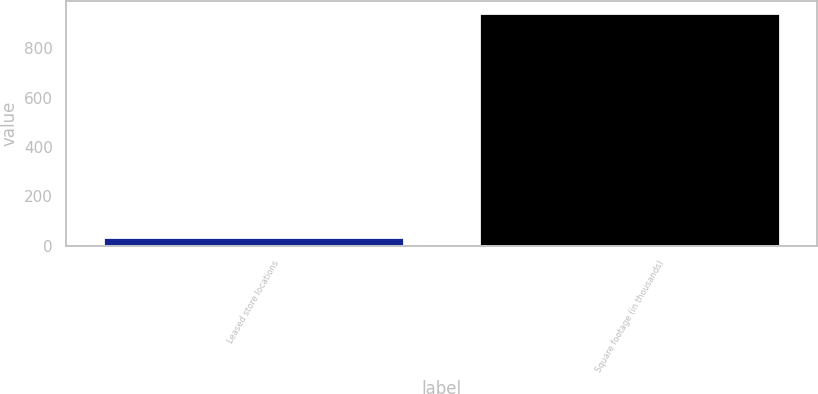<chart> <loc_0><loc_0><loc_500><loc_500><bar_chart><fcel>Leased store locations<fcel>Square footage (in thousands)<nl><fcel>35<fcel>944<nl></chart> 